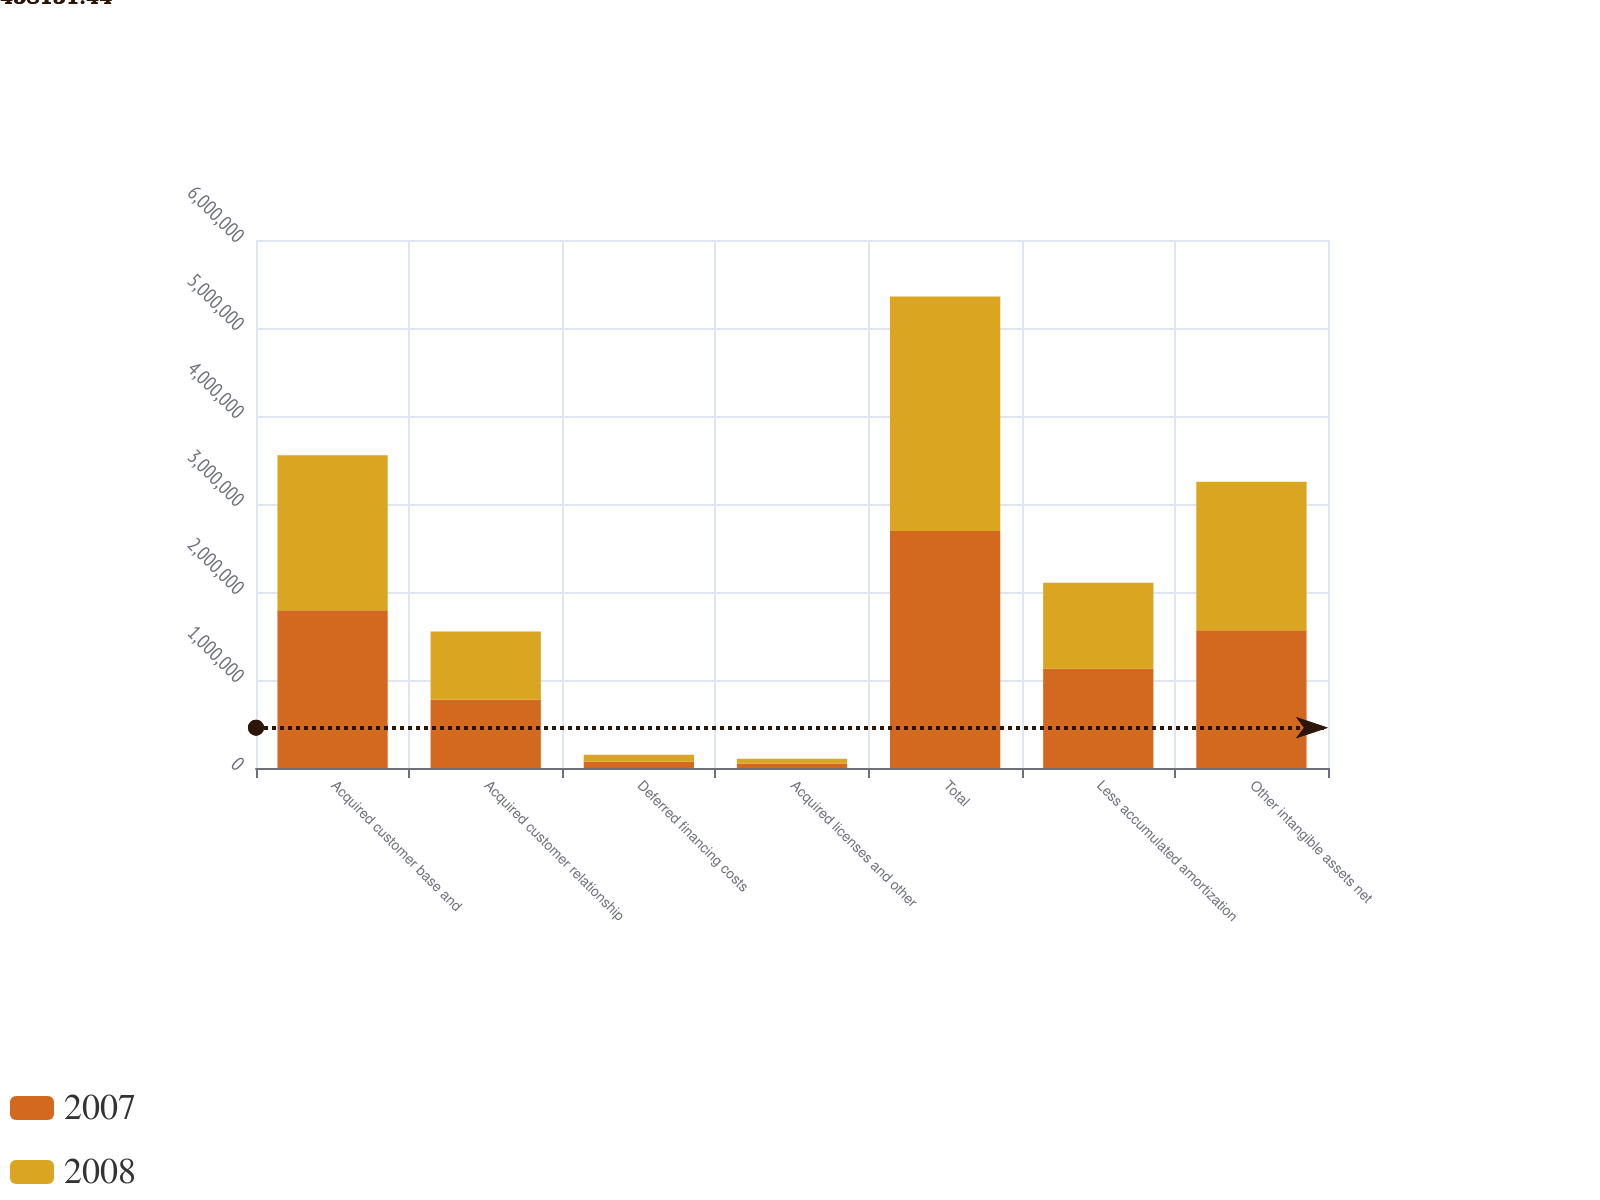<chart> <loc_0><loc_0><loc_500><loc_500><stacked_bar_chart><ecel><fcel>Acquired customer base and<fcel>Acquired customer relationship<fcel>Deferred financing costs<fcel>Acquired licenses and other<fcel>Total<fcel>Less accumulated amortization<fcel>Other intangible assets net<nl><fcel>2007<fcel>1.79242e+06<fcel>775000<fcel>73993<fcel>51866<fcel>2.69328e+06<fcel>1.12712e+06<fcel>1.56616e+06<nl><fcel>2008<fcel>1.76071e+06<fcel>775000<fcel>75934<fcel>53866<fcel>2.66551e+06<fcel>979073<fcel>1.68643e+06<nl></chart> 